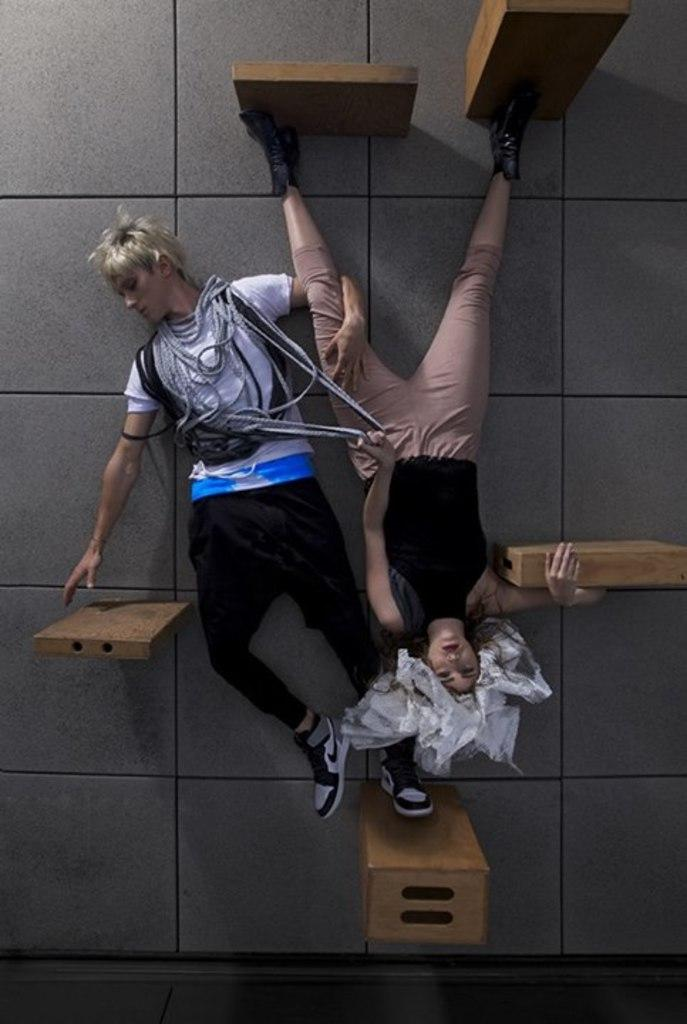How many people are in the image? There are two people in the image. What are the people doing in the image? The people are laying on the floor. What objects can be seen in the image besides the people? There are wooden blocks in the image. What type of pin is the person wearing on their shirt in the image? There is no pin visible on the people's shirts in the image. 